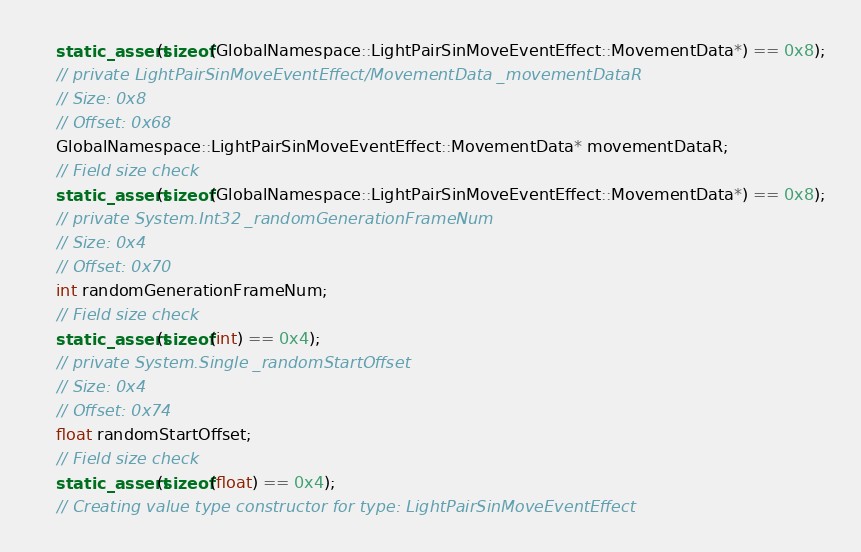<code> <loc_0><loc_0><loc_500><loc_500><_C++_>    static_assert(sizeof(GlobalNamespace::LightPairSinMoveEventEffect::MovementData*) == 0x8);
    // private LightPairSinMoveEventEffect/MovementData _movementDataR
    // Size: 0x8
    // Offset: 0x68
    GlobalNamespace::LightPairSinMoveEventEffect::MovementData* movementDataR;
    // Field size check
    static_assert(sizeof(GlobalNamespace::LightPairSinMoveEventEffect::MovementData*) == 0x8);
    // private System.Int32 _randomGenerationFrameNum
    // Size: 0x4
    // Offset: 0x70
    int randomGenerationFrameNum;
    // Field size check
    static_assert(sizeof(int) == 0x4);
    // private System.Single _randomStartOffset
    // Size: 0x4
    // Offset: 0x74
    float randomStartOffset;
    // Field size check
    static_assert(sizeof(float) == 0x4);
    // Creating value type constructor for type: LightPairSinMoveEventEffect</code> 